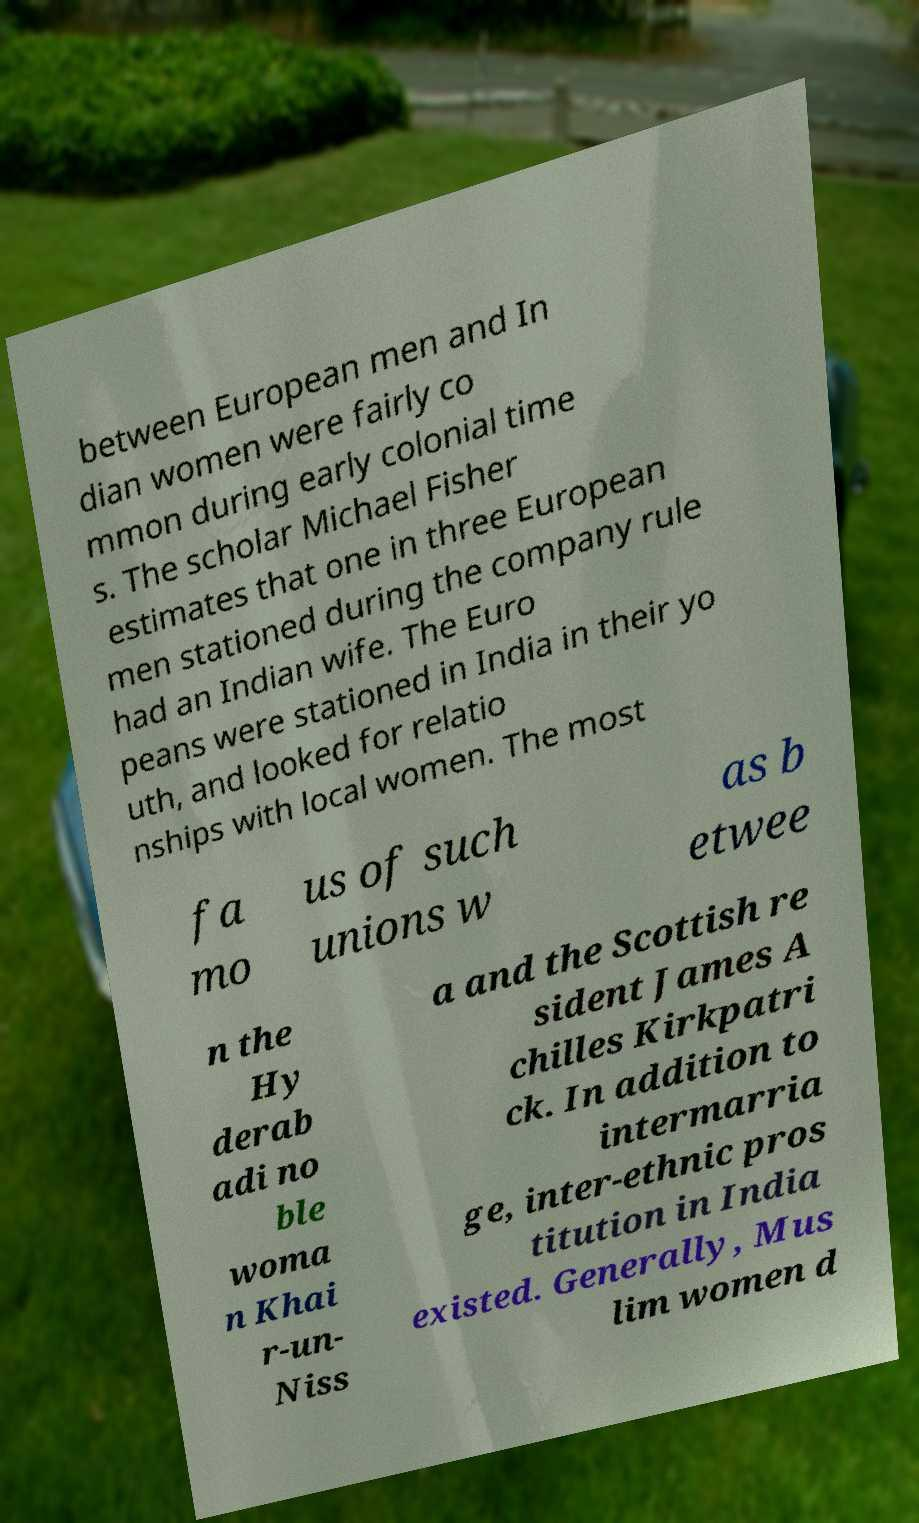For documentation purposes, I need the text within this image transcribed. Could you provide that? between European men and In dian women were fairly co mmon during early colonial time s. The scholar Michael Fisher estimates that one in three European men stationed during the company rule had an Indian wife. The Euro peans were stationed in India in their yo uth, and looked for relatio nships with local women. The most fa mo us of such unions w as b etwee n the Hy derab adi no ble woma n Khai r-un- Niss a and the Scottish re sident James A chilles Kirkpatri ck. In addition to intermarria ge, inter-ethnic pros titution in India existed. Generally, Mus lim women d 